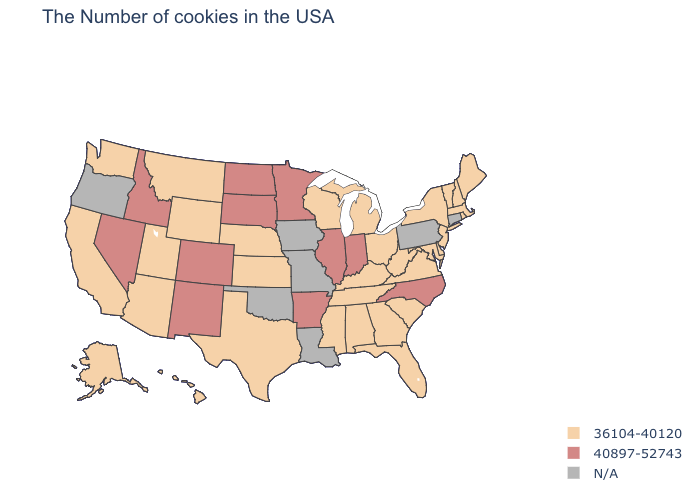Is the legend a continuous bar?
Write a very short answer. No. What is the lowest value in the USA?
Be succinct. 36104-40120. Does the map have missing data?
Answer briefly. Yes. Among the states that border Colorado , which have the highest value?
Be succinct. New Mexico. Name the states that have a value in the range 36104-40120?
Concise answer only. Maine, Massachusetts, Rhode Island, New Hampshire, Vermont, New York, New Jersey, Delaware, Maryland, Virginia, South Carolina, West Virginia, Ohio, Florida, Georgia, Michigan, Kentucky, Alabama, Tennessee, Wisconsin, Mississippi, Kansas, Nebraska, Texas, Wyoming, Utah, Montana, Arizona, California, Washington, Alaska, Hawaii. Name the states that have a value in the range N/A?
Concise answer only. Connecticut, Pennsylvania, Louisiana, Missouri, Iowa, Oklahoma, Oregon. Name the states that have a value in the range 36104-40120?
Write a very short answer. Maine, Massachusetts, Rhode Island, New Hampshire, Vermont, New York, New Jersey, Delaware, Maryland, Virginia, South Carolina, West Virginia, Ohio, Florida, Georgia, Michigan, Kentucky, Alabama, Tennessee, Wisconsin, Mississippi, Kansas, Nebraska, Texas, Wyoming, Utah, Montana, Arizona, California, Washington, Alaska, Hawaii. Name the states that have a value in the range N/A?
Short answer required. Connecticut, Pennsylvania, Louisiana, Missouri, Iowa, Oklahoma, Oregon. Name the states that have a value in the range 36104-40120?
Be succinct. Maine, Massachusetts, Rhode Island, New Hampshire, Vermont, New York, New Jersey, Delaware, Maryland, Virginia, South Carolina, West Virginia, Ohio, Florida, Georgia, Michigan, Kentucky, Alabama, Tennessee, Wisconsin, Mississippi, Kansas, Nebraska, Texas, Wyoming, Utah, Montana, Arizona, California, Washington, Alaska, Hawaii. Name the states that have a value in the range 40897-52743?
Write a very short answer. North Carolina, Indiana, Illinois, Arkansas, Minnesota, South Dakota, North Dakota, Colorado, New Mexico, Idaho, Nevada. Does the first symbol in the legend represent the smallest category?
Keep it brief. Yes. How many symbols are there in the legend?
Be succinct. 3. Name the states that have a value in the range 40897-52743?
Be succinct. North Carolina, Indiana, Illinois, Arkansas, Minnesota, South Dakota, North Dakota, Colorado, New Mexico, Idaho, Nevada. Name the states that have a value in the range N/A?
Concise answer only. Connecticut, Pennsylvania, Louisiana, Missouri, Iowa, Oklahoma, Oregon. 